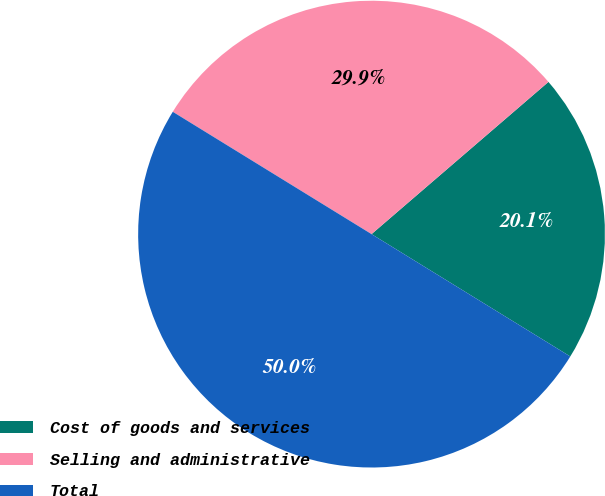<chart> <loc_0><loc_0><loc_500><loc_500><pie_chart><fcel>Cost of goods and services<fcel>Selling and administrative<fcel>Total<nl><fcel>20.09%<fcel>29.91%<fcel>50.0%<nl></chart> 